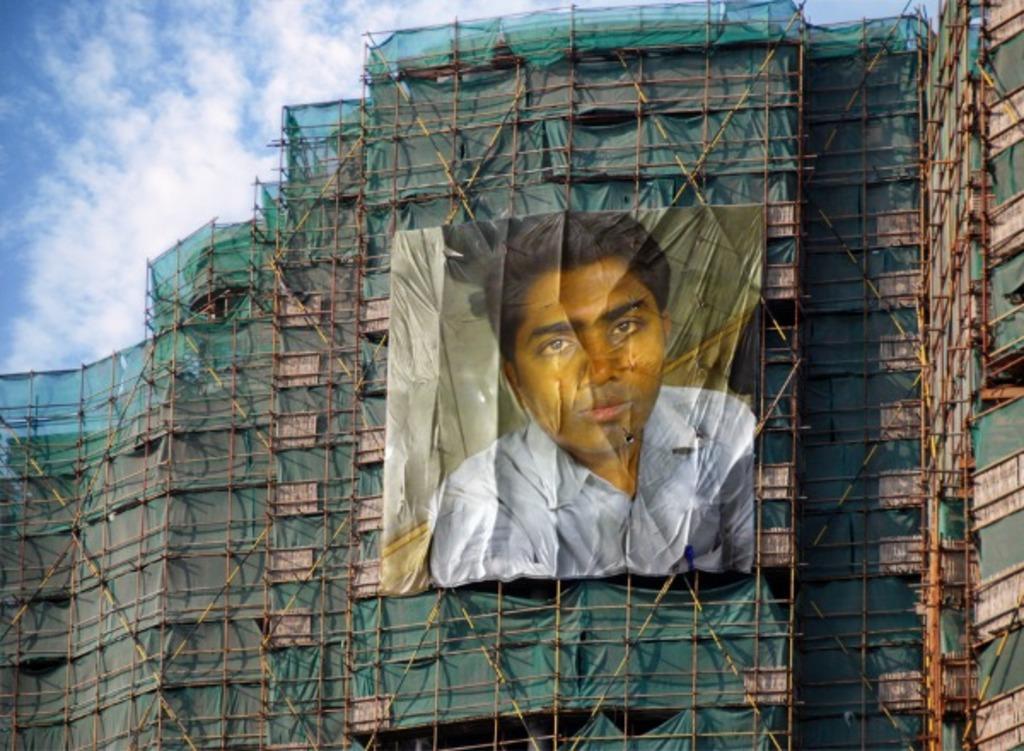In one or two sentences, can you explain what this image depicts? In this picture we can see the poster of a person hanging on an under construction building with many poles and green net. Here the sky is blue. 